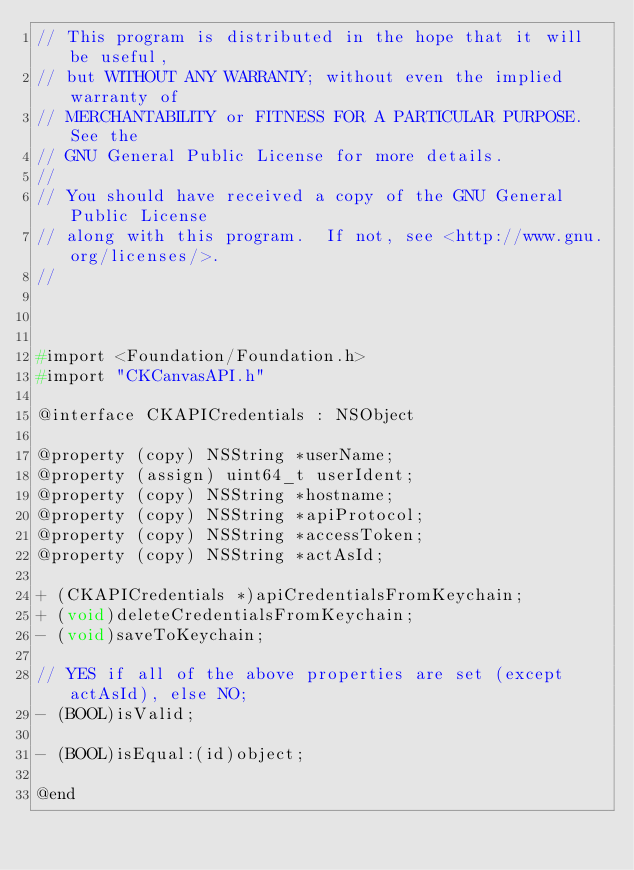<code> <loc_0><loc_0><loc_500><loc_500><_C_>// This program is distributed in the hope that it will be useful,
// but WITHOUT ANY WARRANTY; without even the implied warranty of
// MERCHANTABILITY or FITNESS FOR A PARTICULAR PURPOSE.  See the
// GNU General Public License for more details.
//
// You should have received a copy of the GNU General Public License
// along with this program.  If not, see <http://www.gnu.org/licenses/>.
//
    
    

#import <Foundation/Foundation.h>
#import "CKCanvasAPI.h"

@interface CKAPICredentials : NSObject

@property (copy) NSString *userName;
@property (assign) uint64_t userIdent;
@property (copy) NSString *hostname;
@property (copy) NSString *apiProtocol;
@property (copy) NSString *accessToken;
@property (copy) NSString *actAsId;

+ (CKAPICredentials *)apiCredentialsFromKeychain;
+ (void)deleteCredentialsFromKeychain;
- (void)saveToKeychain;

// YES if all of the above properties are set (except actAsId), else NO;
- (BOOL)isValid;

- (BOOL)isEqual:(id)object;

@end
</code> 